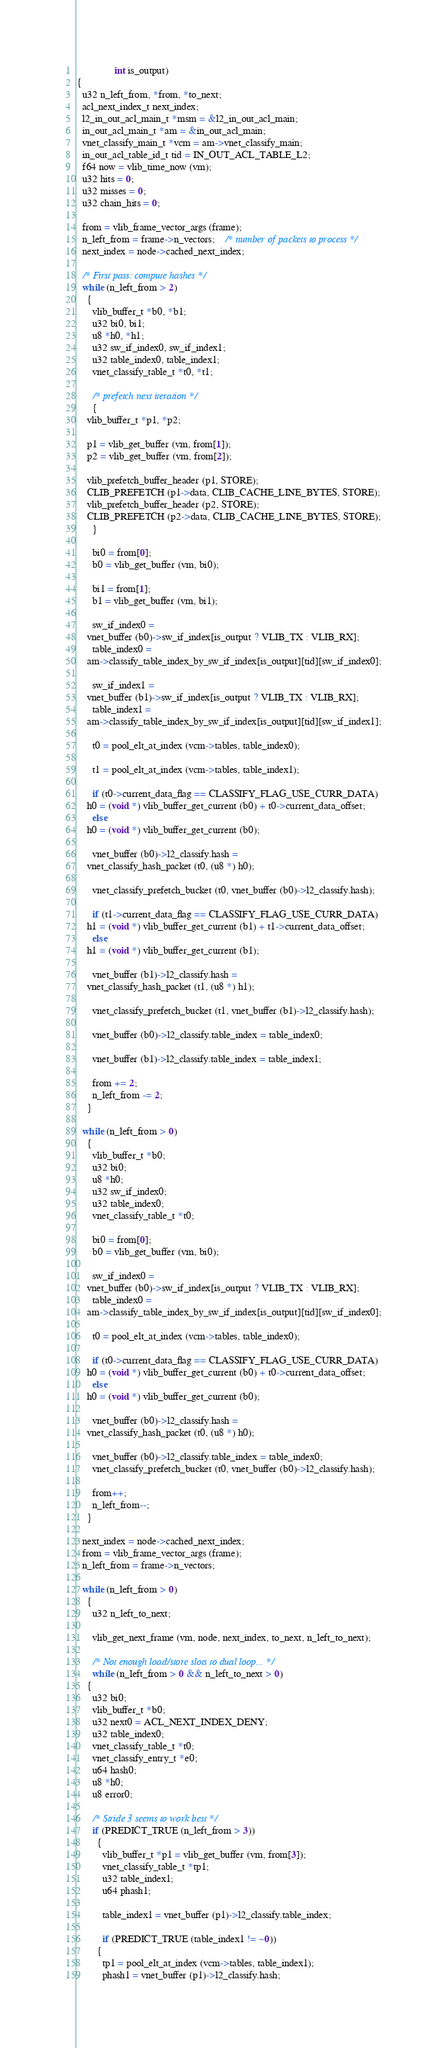<code> <loc_0><loc_0><loc_500><loc_500><_C_>		       int is_output)
{
  u32 n_left_from, *from, *to_next;
  acl_next_index_t next_index;
  l2_in_out_acl_main_t *msm = &l2_in_out_acl_main;
  in_out_acl_main_t *am = &in_out_acl_main;
  vnet_classify_main_t *vcm = am->vnet_classify_main;
  in_out_acl_table_id_t tid = IN_OUT_ACL_TABLE_L2;
  f64 now = vlib_time_now (vm);
  u32 hits = 0;
  u32 misses = 0;
  u32 chain_hits = 0;

  from = vlib_frame_vector_args (frame);
  n_left_from = frame->n_vectors;	/* number of packets to process */
  next_index = node->cached_next_index;

  /* First pass: compute hashes */
  while (n_left_from > 2)
    {
      vlib_buffer_t *b0, *b1;
      u32 bi0, bi1;
      u8 *h0, *h1;
      u32 sw_if_index0, sw_if_index1;
      u32 table_index0, table_index1;
      vnet_classify_table_t *t0, *t1;

      /* prefetch next iteration */
      {
	vlib_buffer_t *p1, *p2;

	p1 = vlib_get_buffer (vm, from[1]);
	p2 = vlib_get_buffer (vm, from[2]);

	vlib_prefetch_buffer_header (p1, STORE);
	CLIB_PREFETCH (p1->data, CLIB_CACHE_LINE_BYTES, STORE);
	vlib_prefetch_buffer_header (p2, STORE);
	CLIB_PREFETCH (p2->data, CLIB_CACHE_LINE_BYTES, STORE);
      }

      bi0 = from[0];
      b0 = vlib_get_buffer (vm, bi0);

      bi1 = from[1];
      b1 = vlib_get_buffer (vm, bi1);

      sw_if_index0 =
	vnet_buffer (b0)->sw_if_index[is_output ? VLIB_TX : VLIB_RX];
      table_index0 =
	am->classify_table_index_by_sw_if_index[is_output][tid][sw_if_index0];

      sw_if_index1 =
	vnet_buffer (b1)->sw_if_index[is_output ? VLIB_TX : VLIB_RX];
      table_index1 =
	am->classify_table_index_by_sw_if_index[is_output][tid][sw_if_index1];

      t0 = pool_elt_at_index (vcm->tables, table_index0);

      t1 = pool_elt_at_index (vcm->tables, table_index1);

      if (t0->current_data_flag == CLASSIFY_FLAG_USE_CURR_DATA)
	h0 = (void *) vlib_buffer_get_current (b0) + t0->current_data_offset;
      else
	h0 = (void *) vlib_buffer_get_current (b0);

      vnet_buffer (b0)->l2_classify.hash =
	vnet_classify_hash_packet (t0, (u8 *) h0);

      vnet_classify_prefetch_bucket (t0, vnet_buffer (b0)->l2_classify.hash);

      if (t1->current_data_flag == CLASSIFY_FLAG_USE_CURR_DATA)
	h1 = (void *) vlib_buffer_get_current (b1) + t1->current_data_offset;
      else
	h1 = (void *) vlib_buffer_get_current (b1);

      vnet_buffer (b1)->l2_classify.hash =
	vnet_classify_hash_packet (t1, (u8 *) h1);

      vnet_classify_prefetch_bucket (t1, vnet_buffer (b1)->l2_classify.hash);

      vnet_buffer (b0)->l2_classify.table_index = table_index0;

      vnet_buffer (b1)->l2_classify.table_index = table_index1;

      from += 2;
      n_left_from -= 2;
    }

  while (n_left_from > 0)
    {
      vlib_buffer_t *b0;
      u32 bi0;
      u8 *h0;
      u32 sw_if_index0;
      u32 table_index0;
      vnet_classify_table_t *t0;

      bi0 = from[0];
      b0 = vlib_get_buffer (vm, bi0);

      sw_if_index0 =
	vnet_buffer (b0)->sw_if_index[is_output ? VLIB_TX : VLIB_RX];
      table_index0 =
	am->classify_table_index_by_sw_if_index[is_output][tid][sw_if_index0];

      t0 = pool_elt_at_index (vcm->tables, table_index0);

      if (t0->current_data_flag == CLASSIFY_FLAG_USE_CURR_DATA)
	h0 = (void *) vlib_buffer_get_current (b0) + t0->current_data_offset;
      else
	h0 = (void *) vlib_buffer_get_current (b0);

      vnet_buffer (b0)->l2_classify.hash =
	vnet_classify_hash_packet (t0, (u8 *) h0);

      vnet_buffer (b0)->l2_classify.table_index = table_index0;
      vnet_classify_prefetch_bucket (t0, vnet_buffer (b0)->l2_classify.hash);

      from++;
      n_left_from--;
    }

  next_index = node->cached_next_index;
  from = vlib_frame_vector_args (frame);
  n_left_from = frame->n_vectors;

  while (n_left_from > 0)
    {
      u32 n_left_to_next;

      vlib_get_next_frame (vm, node, next_index, to_next, n_left_to_next);

      /* Not enough load/store slots to dual loop... */
      while (n_left_from > 0 && n_left_to_next > 0)
	{
	  u32 bi0;
	  vlib_buffer_t *b0;
	  u32 next0 = ACL_NEXT_INDEX_DENY;
	  u32 table_index0;
	  vnet_classify_table_t *t0;
	  vnet_classify_entry_t *e0;
	  u64 hash0;
	  u8 *h0;
	  u8 error0;

	  /* Stride 3 seems to work best */
	  if (PREDICT_TRUE (n_left_from > 3))
	    {
	      vlib_buffer_t *p1 = vlib_get_buffer (vm, from[3]);
	      vnet_classify_table_t *tp1;
	      u32 table_index1;
	      u64 phash1;

	      table_index1 = vnet_buffer (p1)->l2_classify.table_index;

	      if (PREDICT_TRUE (table_index1 != ~0))
		{
		  tp1 = pool_elt_at_index (vcm->tables, table_index1);
		  phash1 = vnet_buffer (p1)->l2_classify.hash;</code> 